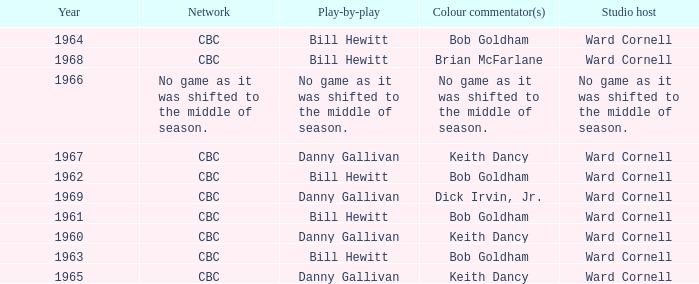Who did the play-by-play with studio host Ward Cornell and color commentator Bob Goldham? Bill Hewitt, Bill Hewitt, Bill Hewitt, Bill Hewitt. 